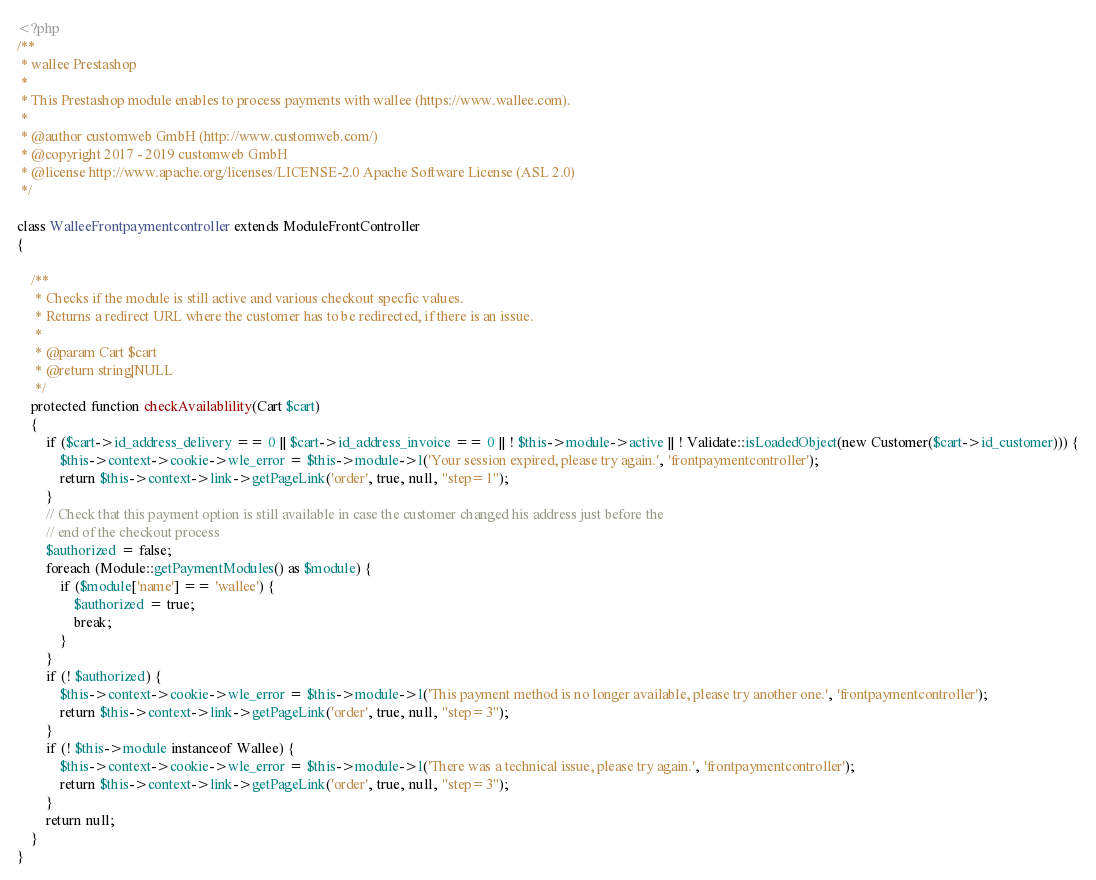<code> <loc_0><loc_0><loc_500><loc_500><_PHP_><?php
/**
 * wallee Prestashop
 *
 * This Prestashop module enables to process payments with wallee (https://www.wallee.com).
 *
 * @author customweb GmbH (http://www.customweb.com/)
 * @copyright 2017 - 2019 customweb GmbH
 * @license http://www.apache.org/licenses/LICENSE-2.0 Apache Software License (ASL 2.0)
 */

class WalleeFrontpaymentcontroller extends ModuleFrontController
{

    /**
     * Checks if the module is still active and various checkout specfic values.
     * Returns a redirect URL where the customer has to be redirected, if there is an issue.
     *
     * @param Cart $cart
     * @return string|NULL
     */
    protected function checkAvailablility(Cart $cart)
    {
        if ($cart->id_address_delivery == 0 || $cart->id_address_invoice == 0 || ! $this->module->active || ! Validate::isLoadedObject(new Customer($cart->id_customer))) {
            $this->context->cookie->wle_error = $this->module->l('Your session expired, please try again.', 'frontpaymentcontroller');
            return $this->context->link->getPageLink('order', true, null, "step=1");
        }
        // Check that this payment option is still available in case the customer changed his address just before the
        // end of the checkout process
        $authorized = false;
        foreach (Module::getPaymentModules() as $module) {
            if ($module['name'] == 'wallee') {
                $authorized = true;
                break;
            }
        }
        if (! $authorized) {
            $this->context->cookie->wle_error = $this->module->l('This payment method is no longer available, please try another one.', 'frontpaymentcontroller');
            return $this->context->link->getPageLink('order', true, null, "step=3");
        }
        if (! $this->module instanceof Wallee) {
            $this->context->cookie->wle_error = $this->module->l('There was a technical issue, please try again.', 'frontpaymentcontroller');
            return $this->context->link->getPageLink('order', true, null, "step=3");
        }
        return null;
    }
}
</code> 